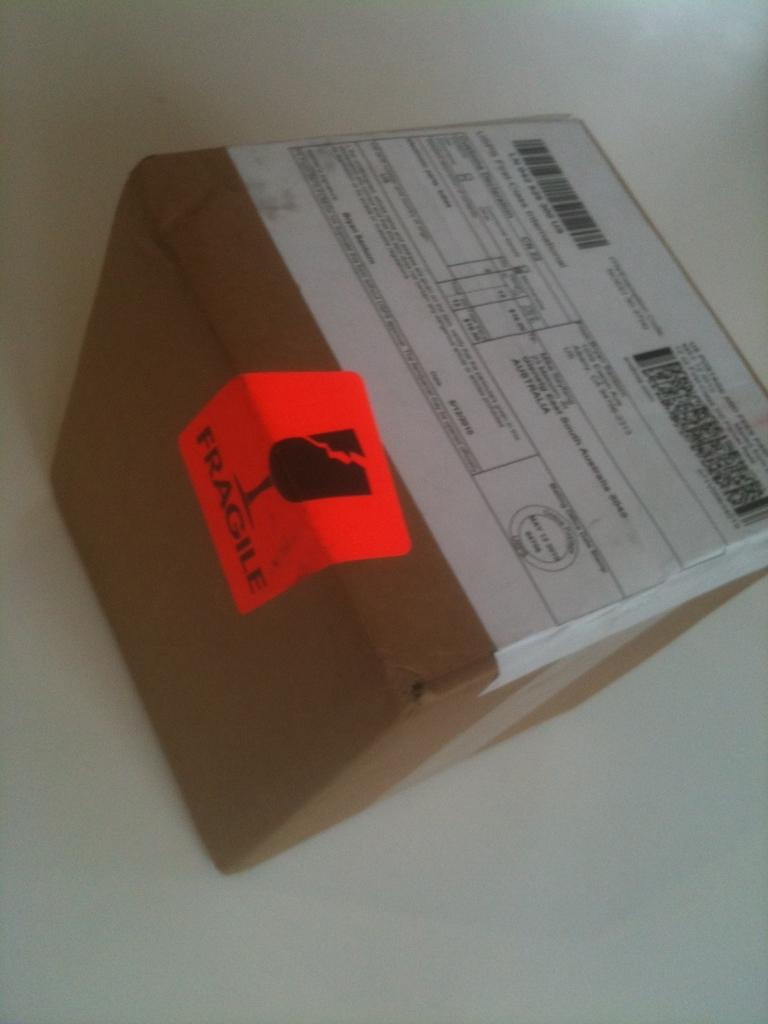Provide a one-sentence caption for the provided image. A box with a shipping label on top and fragile on the side. 